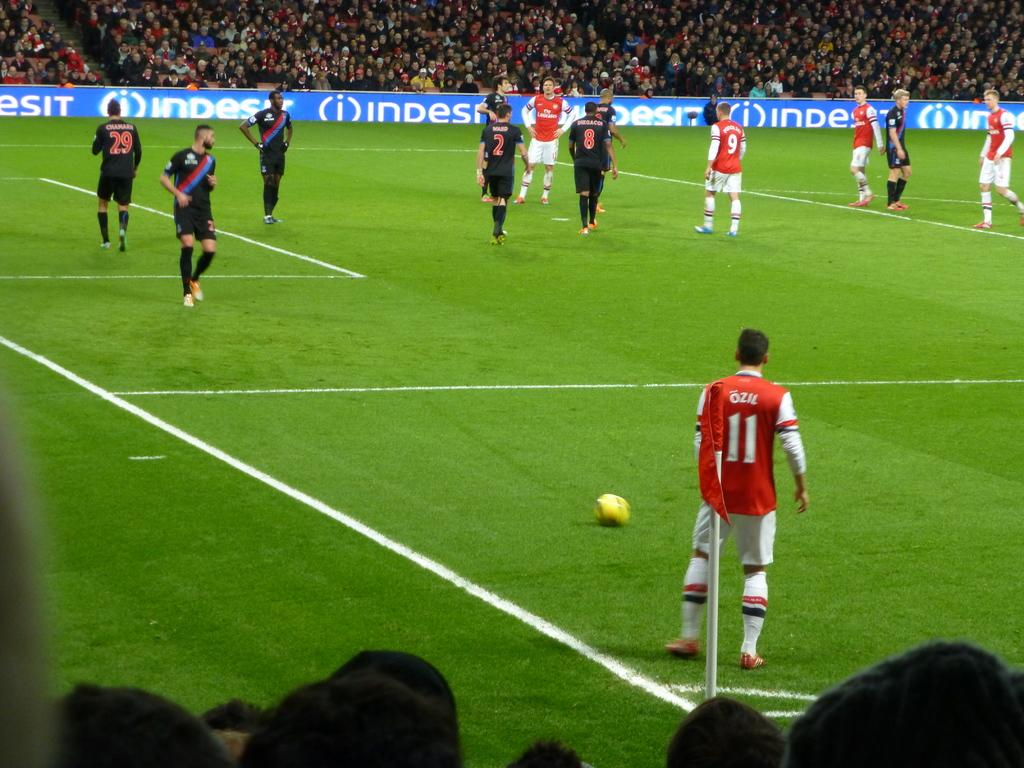<image>
Present a compact description of the photo's key features. Two teams on a soccer field in a stadium surrounded by thousands of people and one player is number 11 